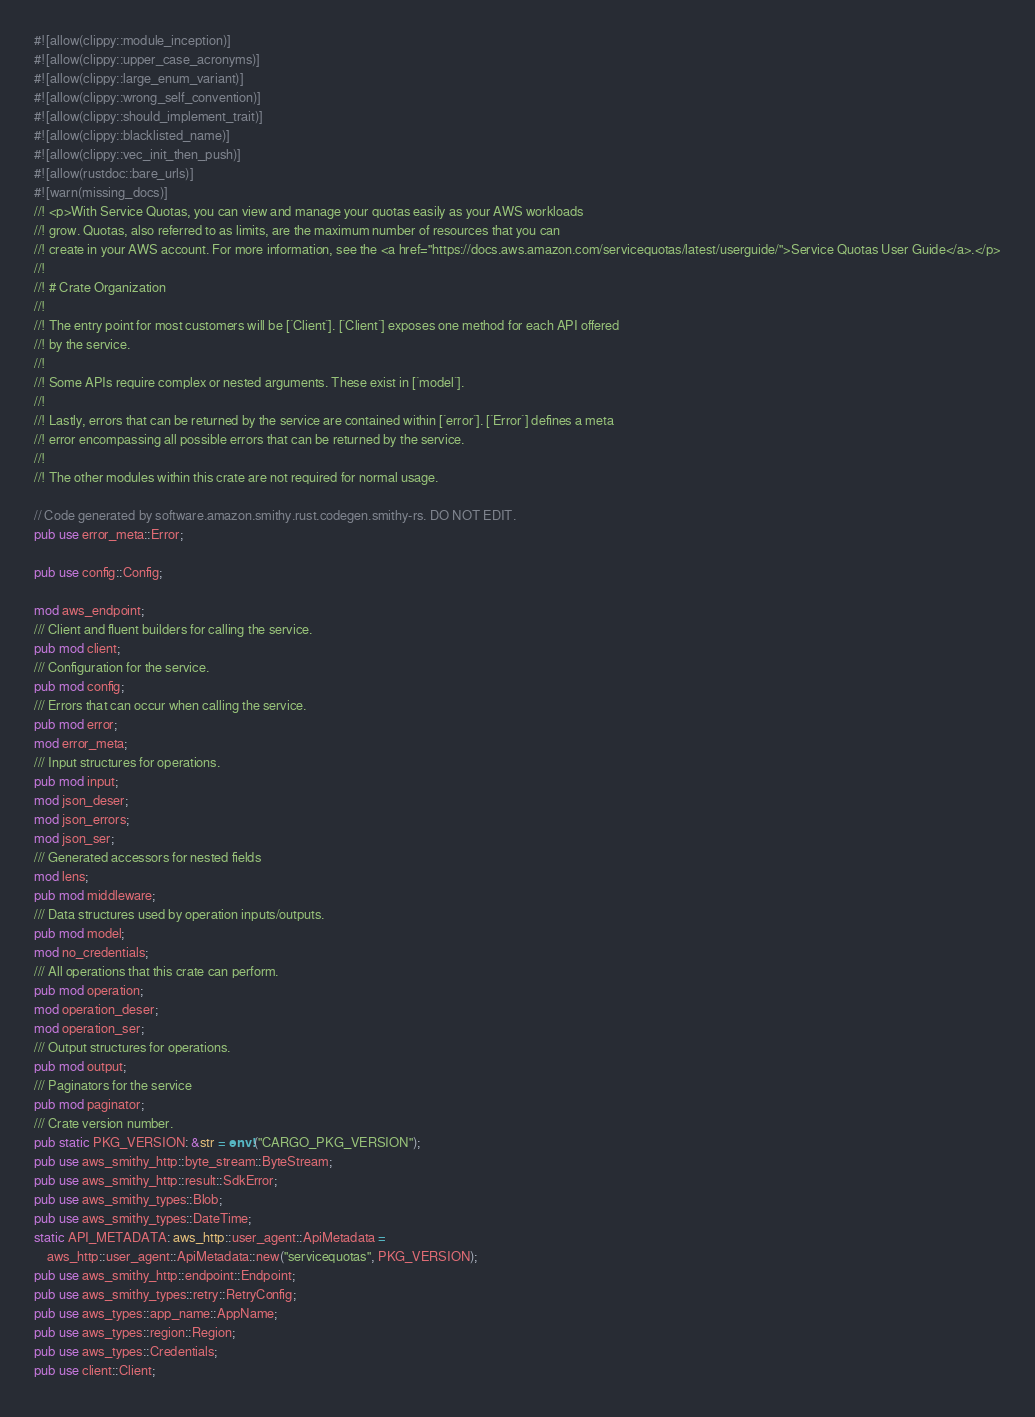Convert code to text. <code><loc_0><loc_0><loc_500><loc_500><_Rust_>#![allow(clippy::module_inception)]
#![allow(clippy::upper_case_acronyms)]
#![allow(clippy::large_enum_variant)]
#![allow(clippy::wrong_self_convention)]
#![allow(clippy::should_implement_trait)]
#![allow(clippy::blacklisted_name)]
#![allow(clippy::vec_init_then_push)]
#![allow(rustdoc::bare_urls)]
#![warn(missing_docs)]
//! <p>With Service Quotas, you can view and manage your quotas easily as your AWS workloads
//! grow. Quotas, also referred to as limits, are the maximum number of resources that you can
//! create in your AWS account. For more information, see the <a href="https://docs.aws.amazon.com/servicequotas/latest/userguide/">Service Quotas User Guide</a>.</p>
//!
//! # Crate Organization
//!
//! The entry point for most customers will be [`Client`]. [`Client`] exposes one method for each API offered
//! by the service.
//!
//! Some APIs require complex or nested arguments. These exist in [`model`].
//!
//! Lastly, errors that can be returned by the service are contained within [`error`]. [`Error`] defines a meta
//! error encompassing all possible errors that can be returned by the service.
//!
//! The other modules within this crate are not required for normal usage.

// Code generated by software.amazon.smithy.rust.codegen.smithy-rs. DO NOT EDIT.
pub use error_meta::Error;

pub use config::Config;

mod aws_endpoint;
/// Client and fluent builders for calling the service.
pub mod client;
/// Configuration for the service.
pub mod config;
/// Errors that can occur when calling the service.
pub mod error;
mod error_meta;
/// Input structures for operations.
pub mod input;
mod json_deser;
mod json_errors;
mod json_ser;
/// Generated accessors for nested fields
mod lens;
pub mod middleware;
/// Data structures used by operation inputs/outputs.
pub mod model;
mod no_credentials;
/// All operations that this crate can perform.
pub mod operation;
mod operation_deser;
mod operation_ser;
/// Output structures for operations.
pub mod output;
/// Paginators for the service
pub mod paginator;
/// Crate version number.
pub static PKG_VERSION: &str = env!("CARGO_PKG_VERSION");
pub use aws_smithy_http::byte_stream::ByteStream;
pub use aws_smithy_http::result::SdkError;
pub use aws_smithy_types::Blob;
pub use aws_smithy_types::DateTime;
static API_METADATA: aws_http::user_agent::ApiMetadata =
    aws_http::user_agent::ApiMetadata::new("servicequotas", PKG_VERSION);
pub use aws_smithy_http::endpoint::Endpoint;
pub use aws_smithy_types::retry::RetryConfig;
pub use aws_types::app_name::AppName;
pub use aws_types::region::Region;
pub use aws_types::Credentials;
pub use client::Client;
</code> 